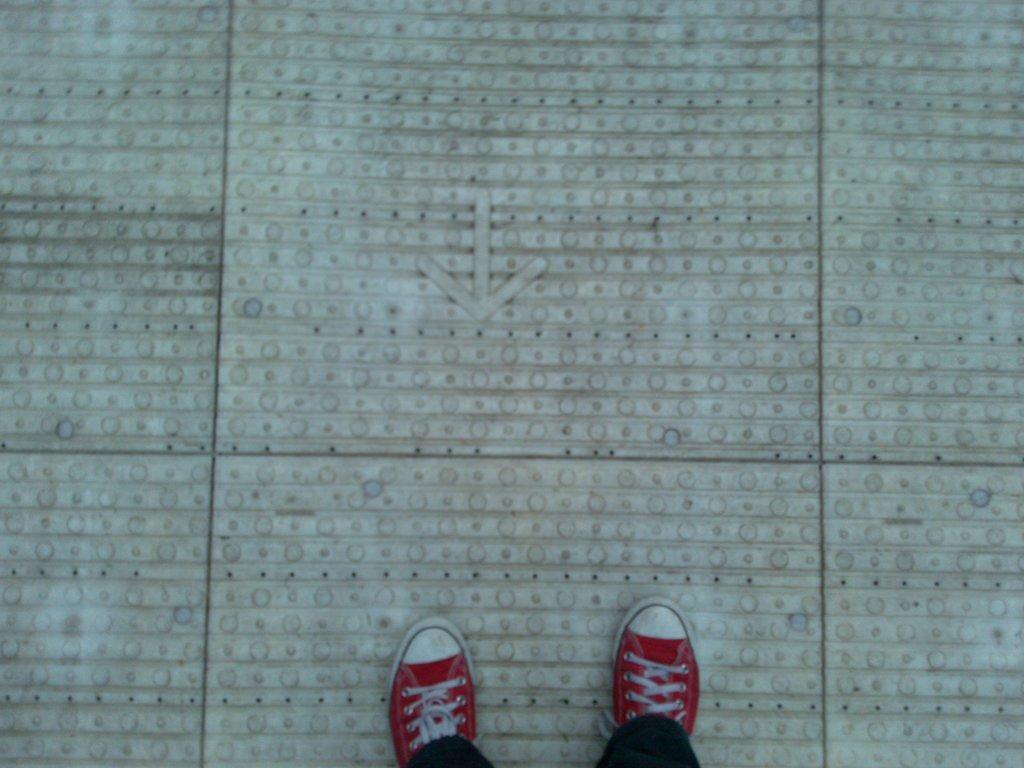How would you summarize this image in a sentence or two? In the picture there is a person wearing shoes and standing on the floor. 